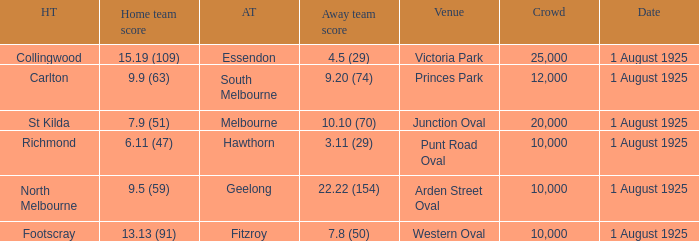What was the away team's score at the match played at The Western Oval? 7.8 (50). 